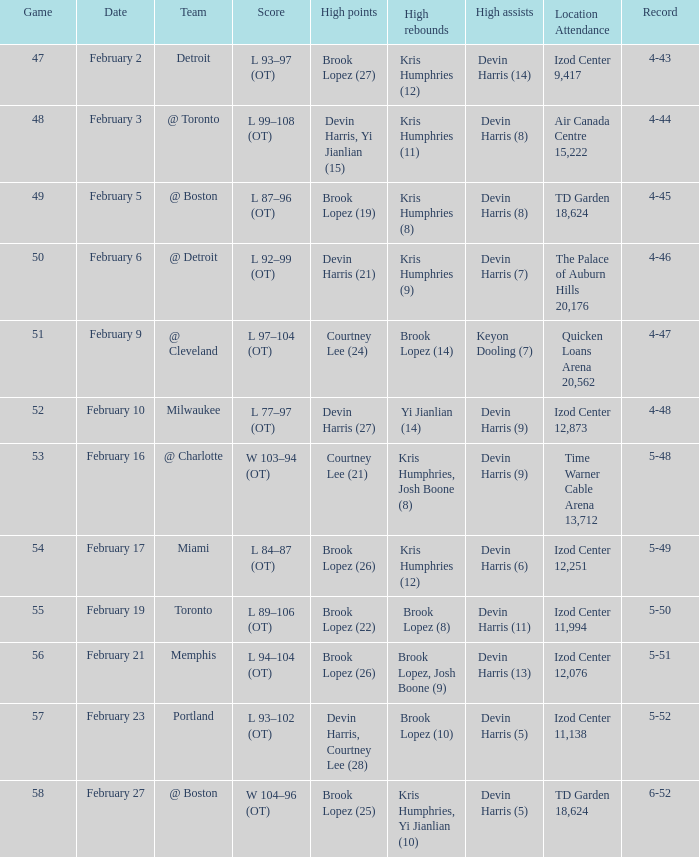What's the highest game number for a game in which Kris Humphries (8) did the high rebounds? 49.0. 